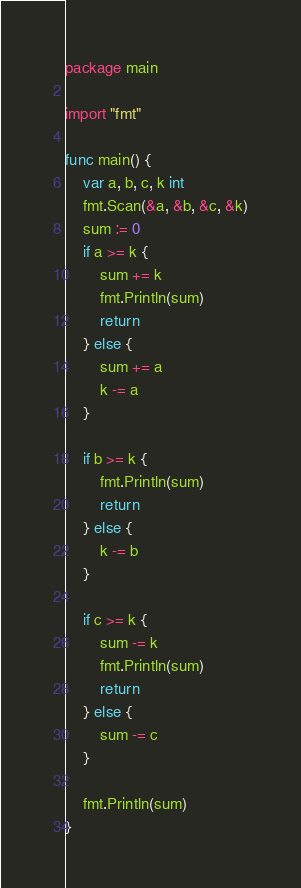<code> <loc_0><loc_0><loc_500><loc_500><_Go_>package main

import "fmt"

func main() {
	var a, b, c, k int
	fmt.Scan(&a, &b, &c, &k)
	sum := 0
	if a >= k {
		sum += k
		fmt.Println(sum)
		return
	} else {
		sum += a
		k -= a
	}

	if b >= k {
		fmt.Println(sum)
		return
	} else {
		k -= b
	}

	if c >= k {
		sum -= k
		fmt.Println(sum)
		return
	} else {
		sum -= c
	}

	fmt.Println(sum)
}
</code> 